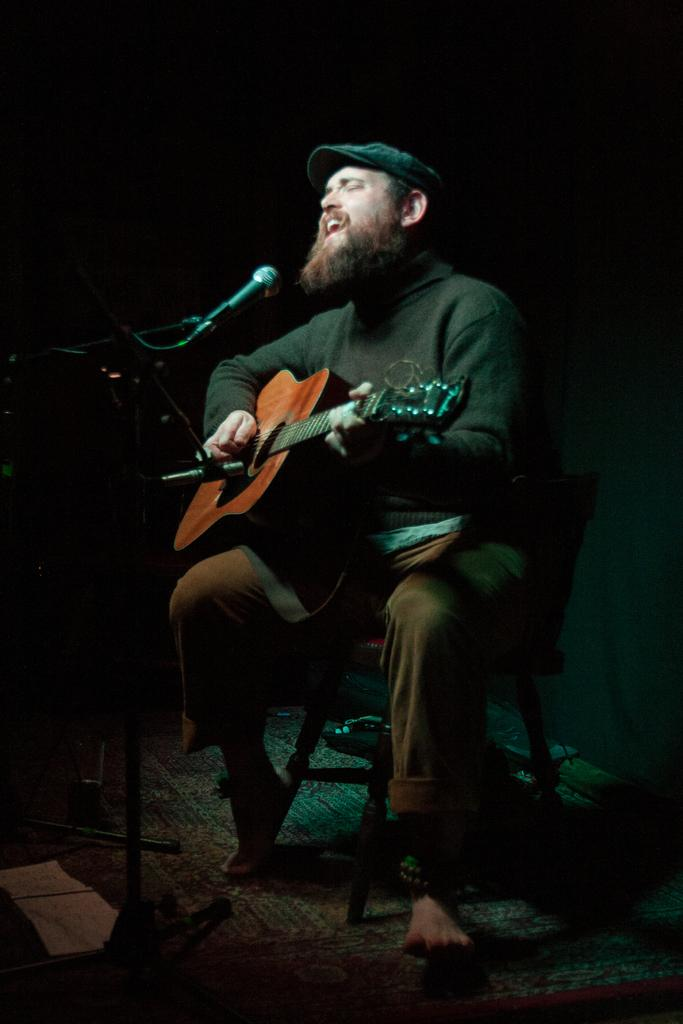Who is the main subject in the image? There is a man in the image. What is the man doing in the image? The man is sitting on a chair and playing a guitar. What object is present in the image that is typically used for amplifying sound? There is a microphone in the image. What type of grape is the man eating in the image? There is no grape present in the image; the man is playing a guitar. How many forks can be seen in the image? There are no forks visible in the image. 